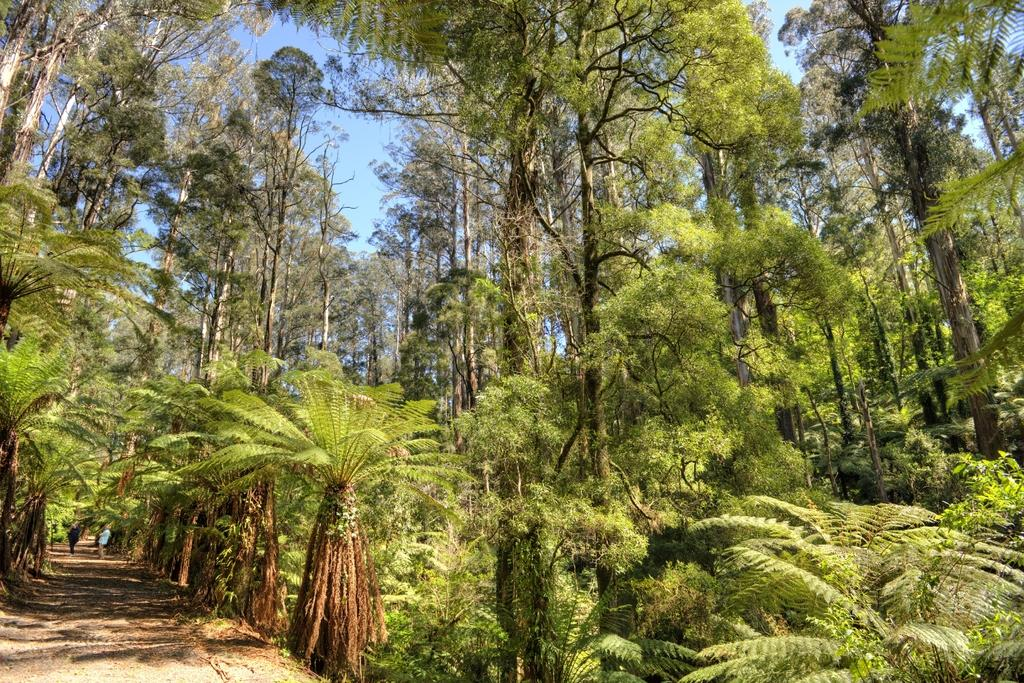What type of vegetation can be seen in the image? There are trees in the image. What else can be seen in the background of the image? There are people visible in the background of the image. What part of the natural environment is visible in the image? The sky is visible in the background of the image. Can you see any edges or rifles in the image? There are no edges or rifles present in the image. 